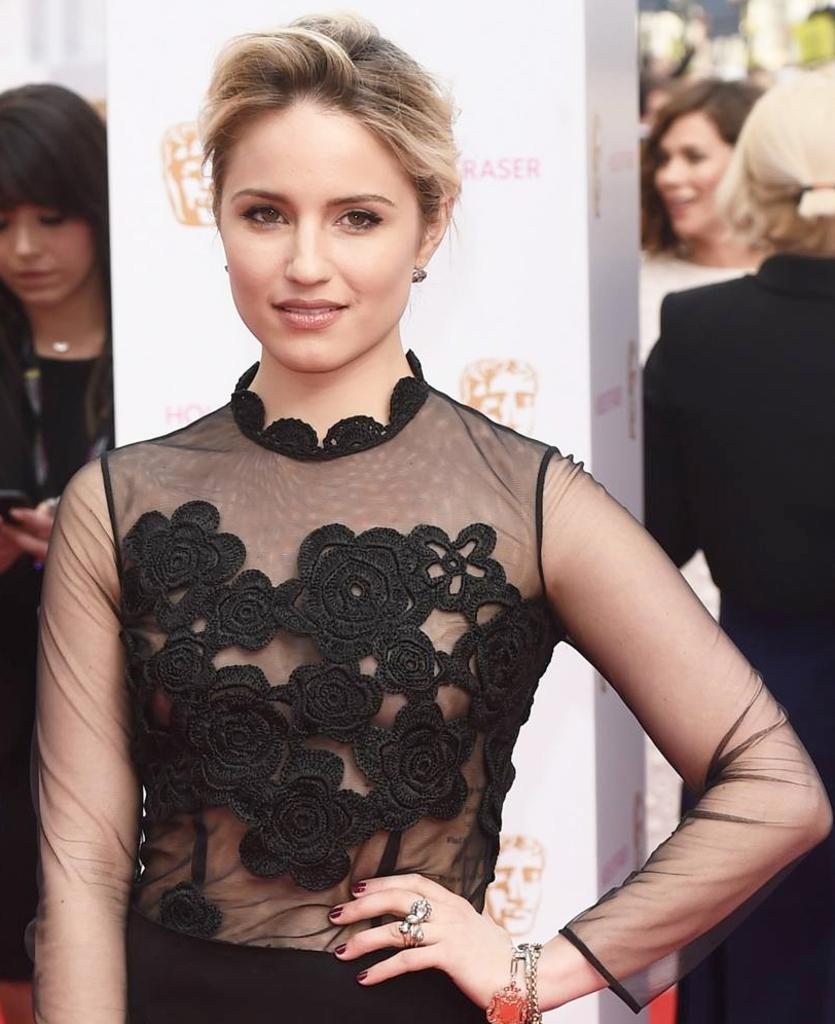What can be seen in the image in terms of people? There is a group of people in the image. What colors are the dresses of the people in the image? Some of the people are wearing white dresses, and some are wearing black dresses. What architectural feature is present in the image? There is a pillar in the image. How would you describe the background of the image? The background of the image is blurred. What type of soup is being served in the image? There is no soup present in the image. Can you see a pen being used by any of the people in the image? There is no pen visible in the image. 